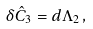<formula> <loc_0><loc_0><loc_500><loc_500>\delta \hat { C } _ { 3 } = d \Lambda _ { 2 } \, ,</formula> 